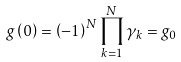Convert formula to latex. <formula><loc_0><loc_0><loc_500><loc_500>g \left ( 0 \right ) = \left ( - 1 \right ) ^ { N } \prod _ { k = 1 } ^ { N } \gamma _ { k } = g _ { 0 }</formula> 